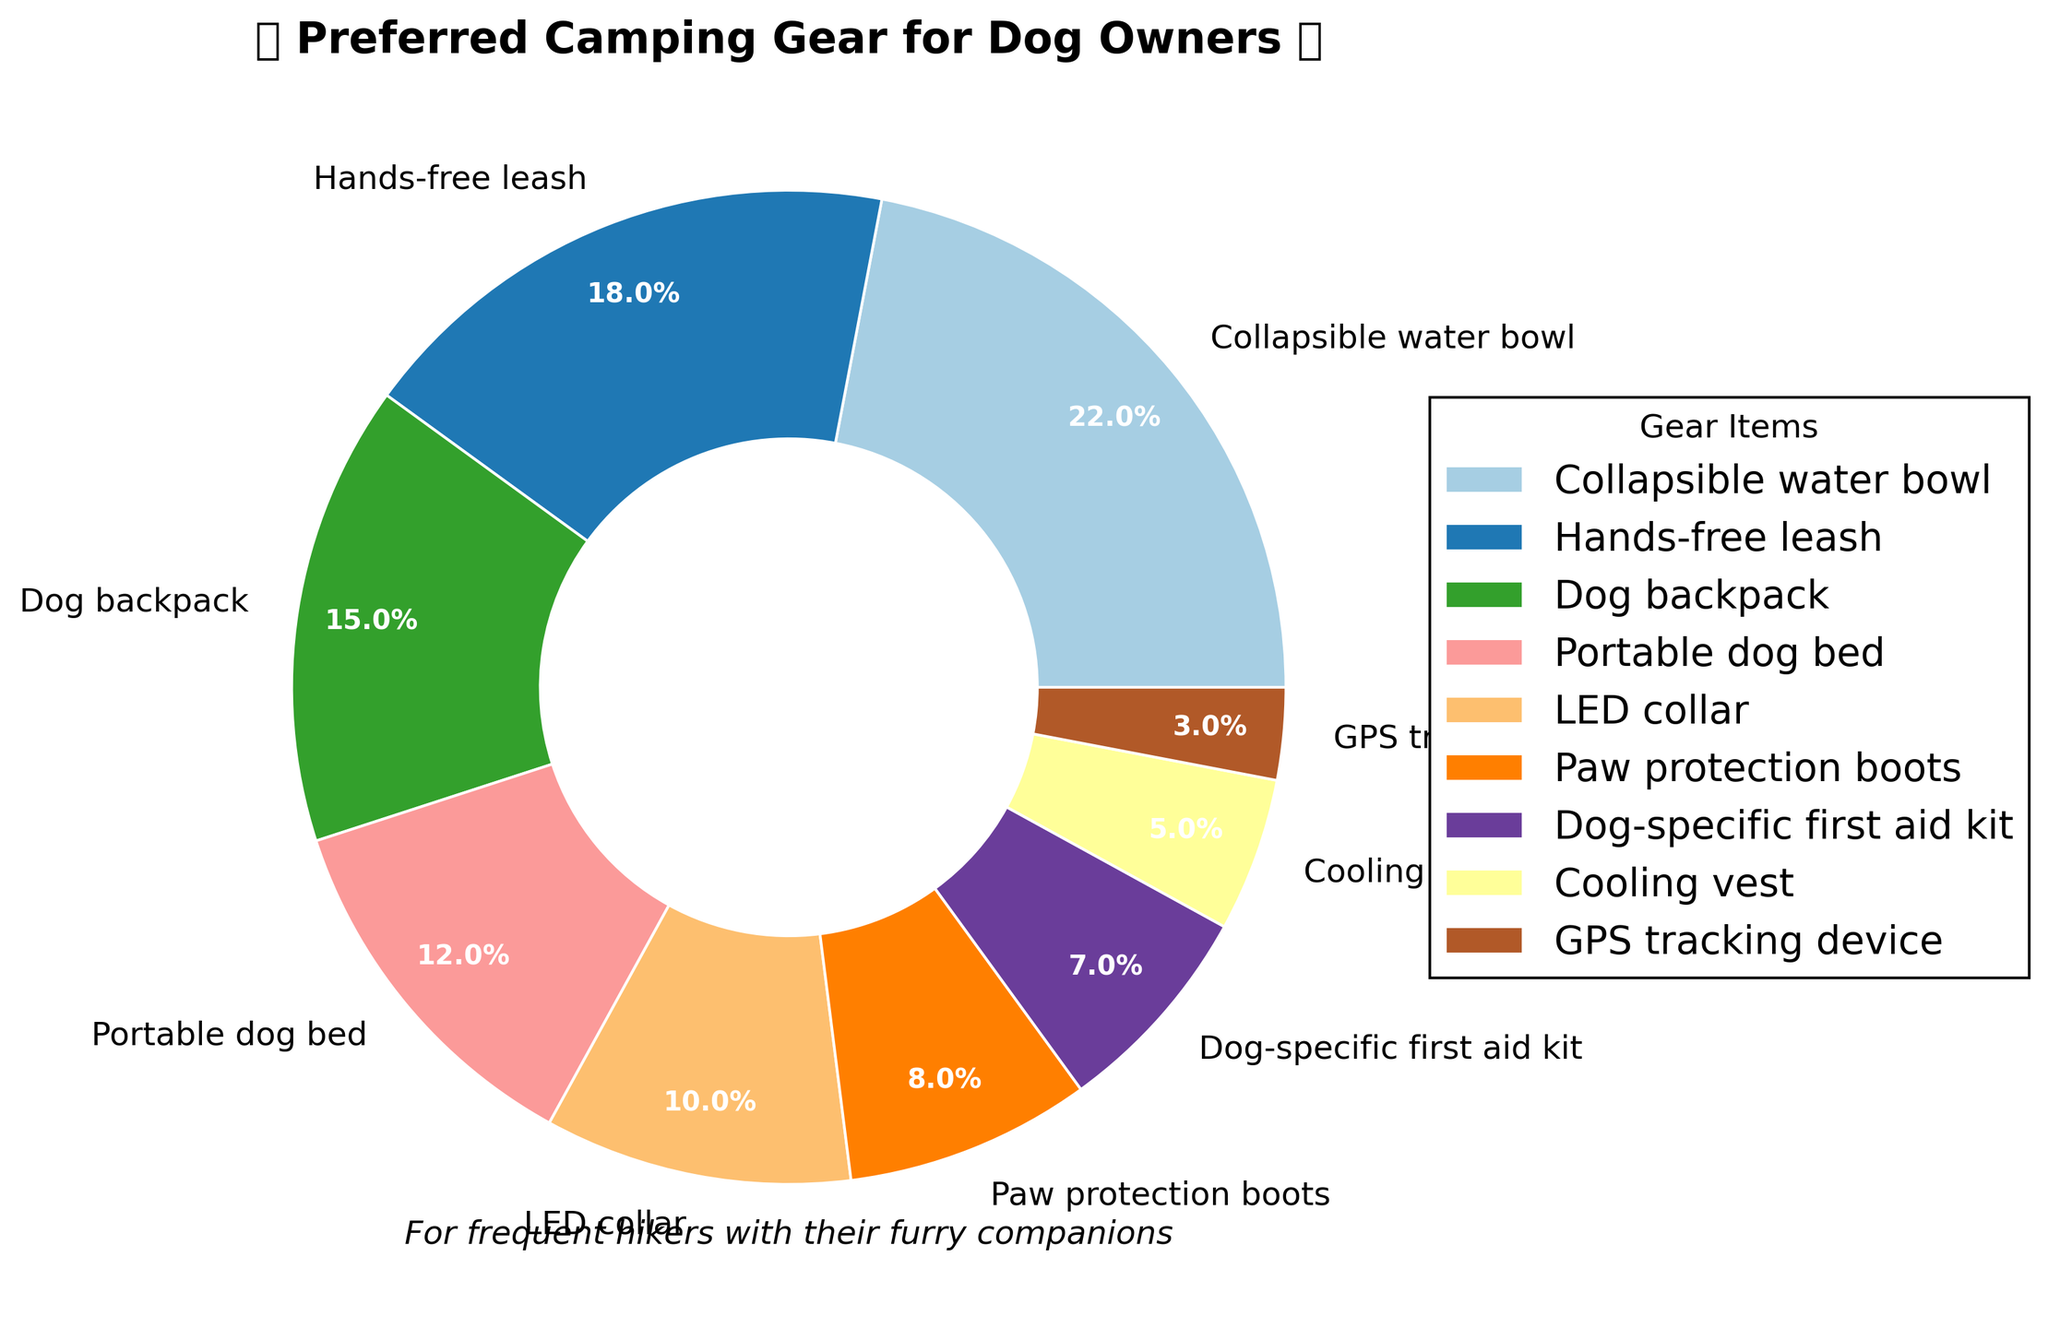Which camping gear item is the most preferred among dog owners? The pie chart shows that the "Collapsible water bowl" has the largest wedge, indicating that it has the highest percentage among all items.
Answer: Collapsible water bowl How much more preferred is the "Hands-free leash" compared to the "Cooling vest"? According to the pie chart, the "Hands-free leash" is 18% and the "Cooling vest" is 5%. So, the difference in preference is 18% - 5% = 13%.
Answer: 13% Which two items combined make up 27% of the pie chart? The pie chart shows "Dog-specific first aid kit" with 7% and "Paw protection boots" with 8%. Adding them together, 7% + 8% = 15%. This sum doesn't match 27%, so checking other combinations: "Hands-free leash" (18%) and "Cooling vest" (5%) add up to 18% + 5% = 23%, which is still not matching. "LED collar" (10%) and "Cooling vest" (5%) add to 10% + 5% = 15%. "GPS tracking device" (3%) and "Cooling vest" (5%) give 3% + 5% = 8%. Finally, "Paw protection boots" (8%) and "Cooling vest" (5%) add to 8% + 5% = 13%. "Dog-specific first aid kit" (7%) and "Dog backpack" (15%) give 7% + 15% = 22%. "Hands-free leash" (18%) and "LED collar" (10%) result in 18% + 10% = 28%. Finally, "Dog-specific first aid kit" (7%) and "Portable dog bed" (12%) provide 7% + 12% = 19%.
Answer: None What percentage of dog owners prefer "Paw protection boots" and "Dog-specific first aid kit" combined? The pie chart shows "Paw protection boots" is preferred by 8% and "Dog-specific first aid kit" by 7%. Their combined percentage is 8% + 7% = 15%.
Answer: 15% Which item is least preferred by the dog owners according to the pie chart? The smallest wedge in the pie chart represents the "GPS tracking device," which is preferred by only 3% of the dog owners.
Answer: GPS tracking device How much more do dog owners prefer "Collapsible water bowl" over "Dog-specific first aid kit"? The preference for the "Collapsible water bowl" is 22% and for the "Dog-specific first aid kit" is 7%. The difference is 22% - 7% = 15%.
Answer: 15% Is the percentage of preference for "Hands-free leash" more than double that for "Cooling vest"? The preference for the "Hands-free leash" is 18%, and for the "Cooling vest" is 5%. Doubling the "Cooling vest" percentage gives 2 * 5% = 10%. Since 18% is more than 10%, "Hands-free leash" is indeed more than double that of "Cooling vest".
Answer: Yes What is the combined preference of the three least preferred items? The three least preferred items according to the pie chart are "Cooling vest" (5%), "GPS tracking device" (3%), and "Dog-specific first aid kit" (7%). Their combined preference is 5% + 3% + 7% = 15%.
Answer: 15% 